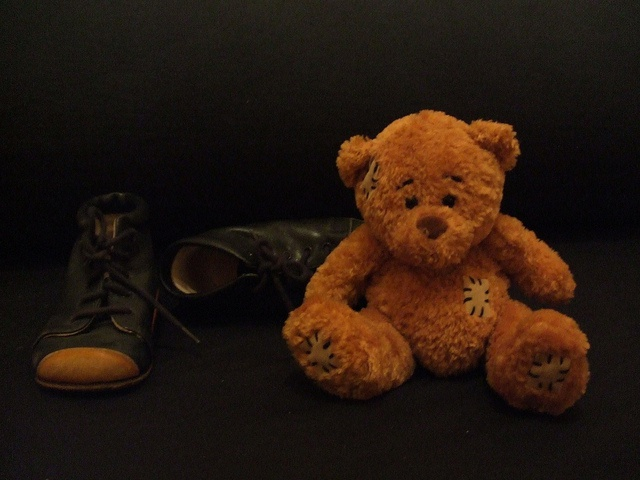Describe the objects in this image and their specific colors. I can see a teddy bear in black, maroon, and brown tones in this image. 